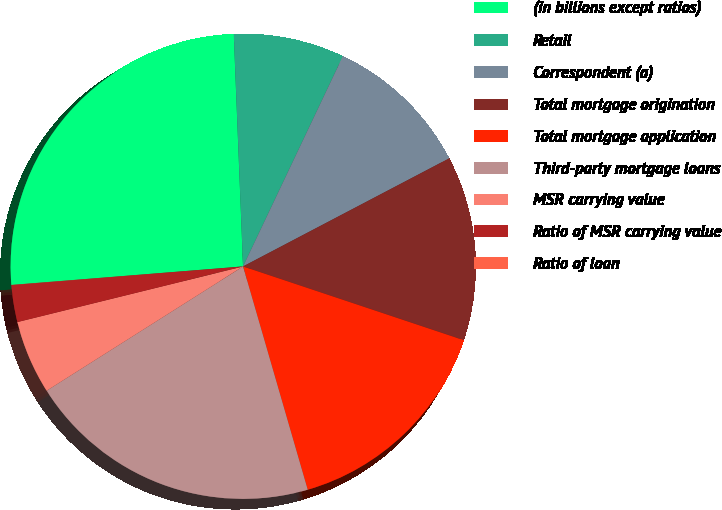Convert chart to OTSL. <chart><loc_0><loc_0><loc_500><loc_500><pie_chart><fcel>(in billions except ratios)<fcel>Retail<fcel>Correspondent (a)<fcel>Total mortgage origination<fcel>Total mortgage application<fcel>Third-party mortgage loans<fcel>MSR carrying value<fcel>Ratio of MSR carrying value<fcel>Ratio of loan<nl><fcel>25.63%<fcel>7.69%<fcel>10.26%<fcel>12.82%<fcel>15.38%<fcel>20.51%<fcel>5.13%<fcel>2.57%<fcel>0.01%<nl></chart> 